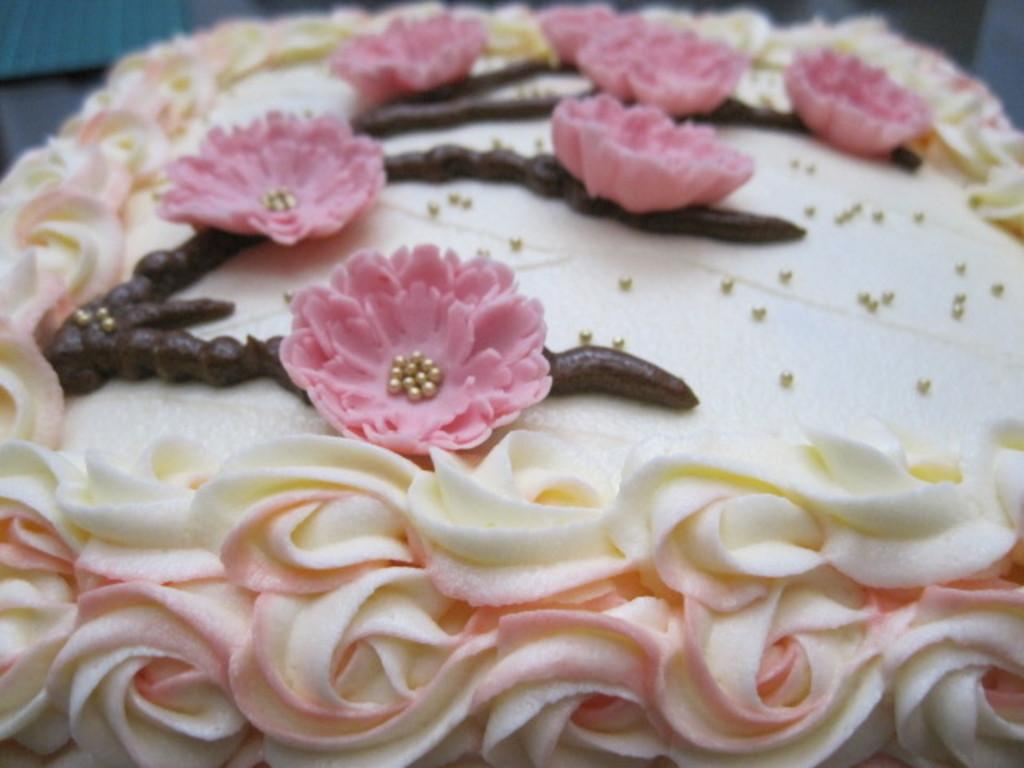What is the main subject of the image? The main subject of the image is a cake. Can you describe the colors of the cake? The cake has cream, brown, and pink colors. How many books are stacked on top of the cake in the image? There are no books present in the image, as it features a cake with various colors. 